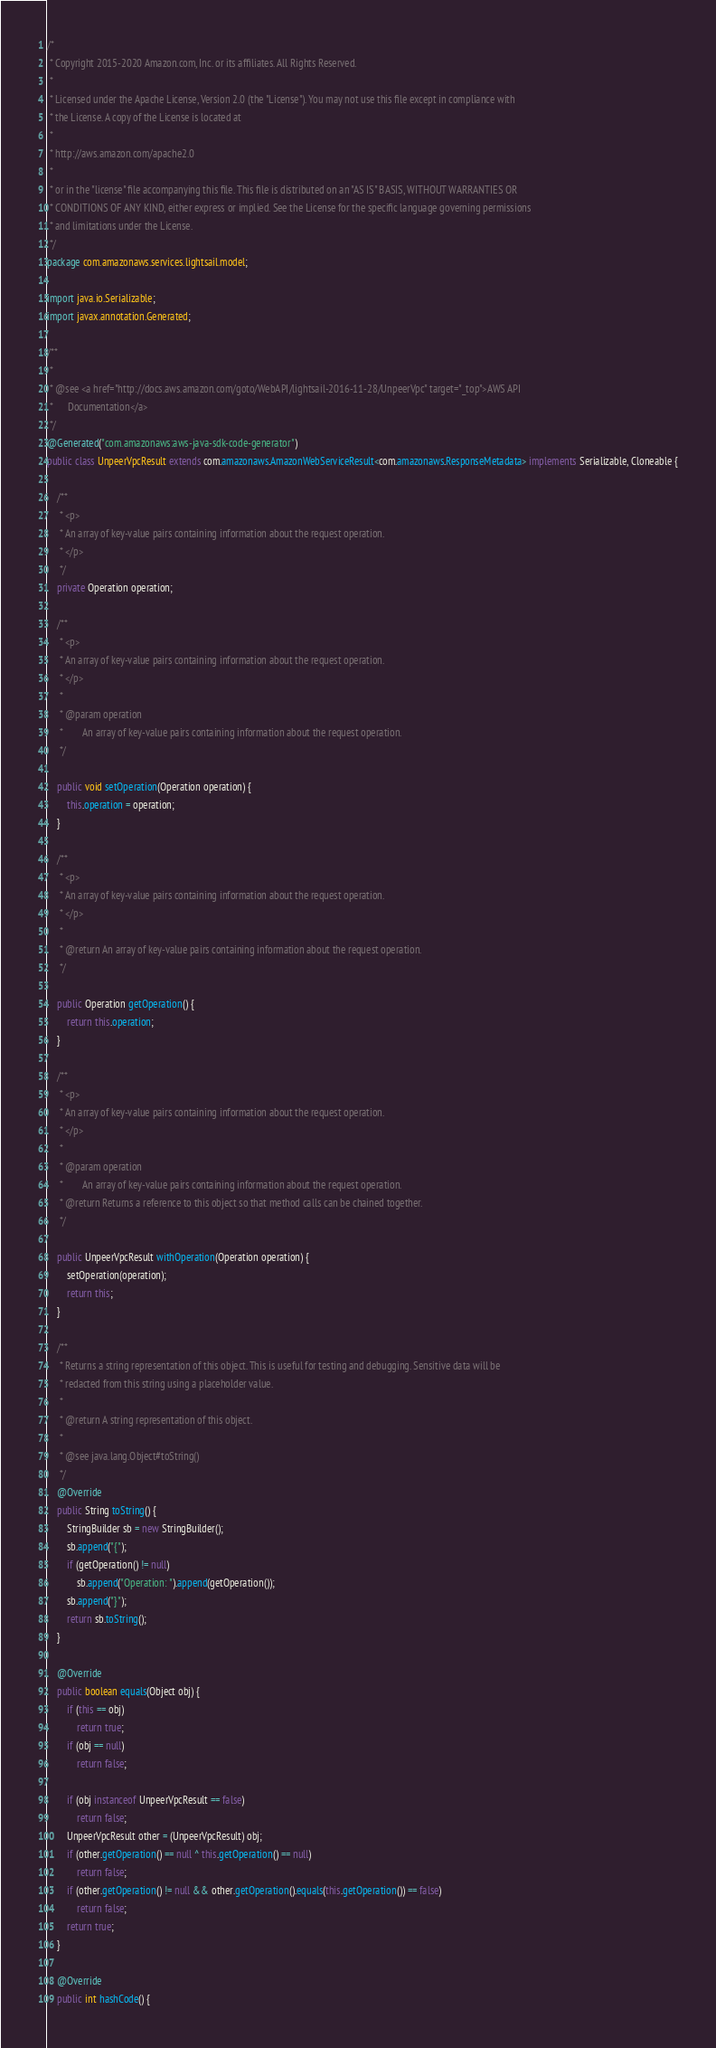Convert code to text. <code><loc_0><loc_0><loc_500><loc_500><_Java_>/*
 * Copyright 2015-2020 Amazon.com, Inc. or its affiliates. All Rights Reserved.
 * 
 * Licensed under the Apache License, Version 2.0 (the "License"). You may not use this file except in compliance with
 * the License. A copy of the License is located at
 * 
 * http://aws.amazon.com/apache2.0
 * 
 * or in the "license" file accompanying this file. This file is distributed on an "AS IS" BASIS, WITHOUT WARRANTIES OR
 * CONDITIONS OF ANY KIND, either express or implied. See the License for the specific language governing permissions
 * and limitations under the License.
 */
package com.amazonaws.services.lightsail.model;

import java.io.Serializable;
import javax.annotation.Generated;

/**
 * 
 * @see <a href="http://docs.aws.amazon.com/goto/WebAPI/lightsail-2016-11-28/UnpeerVpc" target="_top">AWS API
 *      Documentation</a>
 */
@Generated("com.amazonaws:aws-java-sdk-code-generator")
public class UnpeerVpcResult extends com.amazonaws.AmazonWebServiceResult<com.amazonaws.ResponseMetadata> implements Serializable, Cloneable {

    /**
     * <p>
     * An array of key-value pairs containing information about the request operation.
     * </p>
     */
    private Operation operation;

    /**
     * <p>
     * An array of key-value pairs containing information about the request operation.
     * </p>
     * 
     * @param operation
     *        An array of key-value pairs containing information about the request operation.
     */

    public void setOperation(Operation operation) {
        this.operation = operation;
    }

    /**
     * <p>
     * An array of key-value pairs containing information about the request operation.
     * </p>
     * 
     * @return An array of key-value pairs containing information about the request operation.
     */

    public Operation getOperation() {
        return this.operation;
    }

    /**
     * <p>
     * An array of key-value pairs containing information about the request operation.
     * </p>
     * 
     * @param operation
     *        An array of key-value pairs containing information about the request operation.
     * @return Returns a reference to this object so that method calls can be chained together.
     */

    public UnpeerVpcResult withOperation(Operation operation) {
        setOperation(operation);
        return this;
    }

    /**
     * Returns a string representation of this object. This is useful for testing and debugging. Sensitive data will be
     * redacted from this string using a placeholder value.
     *
     * @return A string representation of this object.
     *
     * @see java.lang.Object#toString()
     */
    @Override
    public String toString() {
        StringBuilder sb = new StringBuilder();
        sb.append("{");
        if (getOperation() != null)
            sb.append("Operation: ").append(getOperation());
        sb.append("}");
        return sb.toString();
    }

    @Override
    public boolean equals(Object obj) {
        if (this == obj)
            return true;
        if (obj == null)
            return false;

        if (obj instanceof UnpeerVpcResult == false)
            return false;
        UnpeerVpcResult other = (UnpeerVpcResult) obj;
        if (other.getOperation() == null ^ this.getOperation() == null)
            return false;
        if (other.getOperation() != null && other.getOperation().equals(this.getOperation()) == false)
            return false;
        return true;
    }

    @Override
    public int hashCode() {</code> 